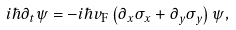Convert formula to latex. <formula><loc_0><loc_0><loc_500><loc_500>i \hbar { \partial } _ { t } \psi = - i \hbar { v } _ { \text {F} } \left ( \partial _ { x } \sigma _ { x } + \partial _ { y } \sigma _ { y } \right ) \psi ,</formula> 